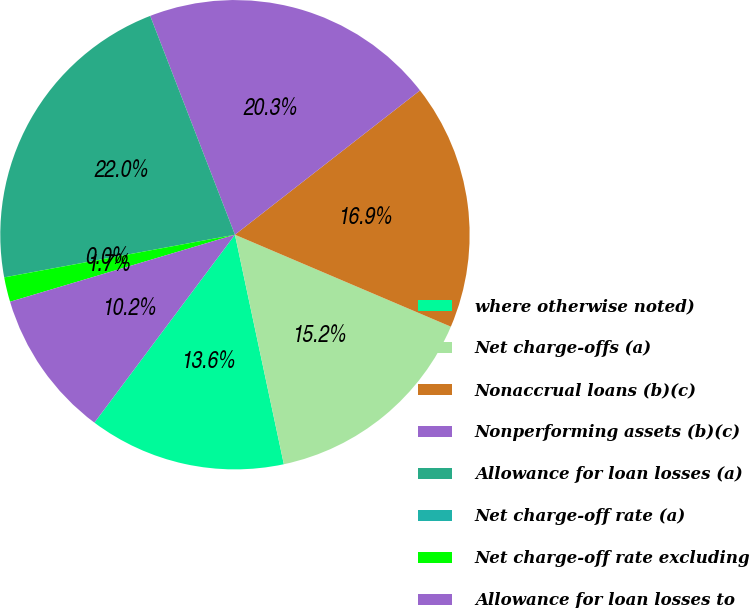Convert chart. <chart><loc_0><loc_0><loc_500><loc_500><pie_chart><fcel>where otherwise noted)<fcel>Net charge-offs (a)<fcel>Nonaccrual loans (b)(c)<fcel>Nonperforming assets (b)(c)<fcel>Allowance for loan losses (a)<fcel>Net charge-off rate (a)<fcel>Net charge-off rate excluding<fcel>Allowance for loan losses to<nl><fcel>13.56%<fcel>15.25%<fcel>16.95%<fcel>20.34%<fcel>22.03%<fcel>0.0%<fcel>1.7%<fcel>10.17%<nl></chart> 